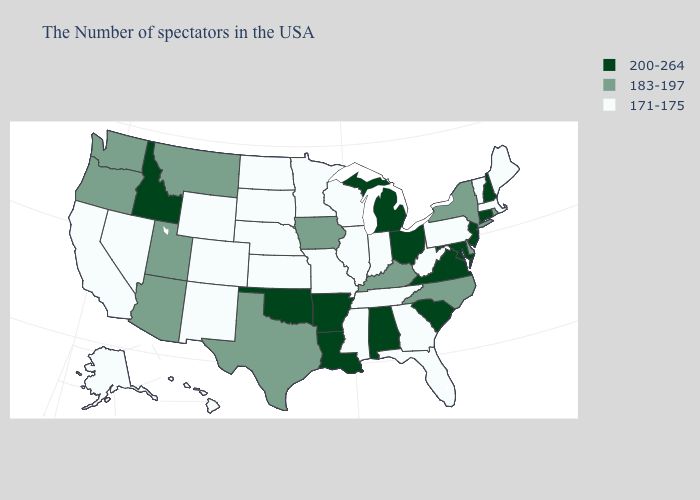Which states have the lowest value in the USA?
Short answer required. Maine, Massachusetts, Vermont, Pennsylvania, West Virginia, Florida, Georgia, Indiana, Tennessee, Wisconsin, Illinois, Mississippi, Missouri, Minnesota, Kansas, Nebraska, South Dakota, North Dakota, Wyoming, Colorado, New Mexico, Nevada, California, Alaska, Hawaii. What is the value of Alabama?
Keep it brief. 200-264. Which states have the highest value in the USA?
Write a very short answer. New Hampshire, Connecticut, New Jersey, Maryland, Virginia, South Carolina, Ohio, Michigan, Alabama, Louisiana, Arkansas, Oklahoma, Idaho. What is the highest value in the South ?
Quick response, please. 200-264. What is the value of New York?
Keep it brief. 183-197. What is the highest value in the USA?
Give a very brief answer. 200-264. Among the states that border Arizona , does New Mexico have the highest value?
Write a very short answer. No. Which states have the lowest value in the USA?
Write a very short answer. Maine, Massachusetts, Vermont, Pennsylvania, West Virginia, Florida, Georgia, Indiana, Tennessee, Wisconsin, Illinois, Mississippi, Missouri, Minnesota, Kansas, Nebraska, South Dakota, North Dakota, Wyoming, Colorado, New Mexico, Nevada, California, Alaska, Hawaii. Does the map have missing data?
Keep it brief. No. Name the states that have a value in the range 171-175?
Concise answer only. Maine, Massachusetts, Vermont, Pennsylvania, West Virginia, Florida, Georgia, Indiana, Tennessee, Wisconsin, Illinois, Mississippi, Missouri, Minnesota, Kansas, Nebraska, South Dakota, North Dakota, Wyoming, Colorado, New Mexico, Nevada, California, Alaska, Hawaii. Does Arkansas have a lower value than Virginia?
Answer briefly. No. Does Texas have the highest value in the USA?
Be succinct. No. Among the states that border Texas , does New Mexico have the highest value?
Quick response, please. No. What is the value of Iowa?
Quick response, please. 183-197. Name the states that have a value in the range 183-197?
Concise answer only. Rhode Island, New York, Delaware, North Carolina, Kentucky, Iowa, Texas, Utah, Montana, Arizona, Washington, Oregon. 